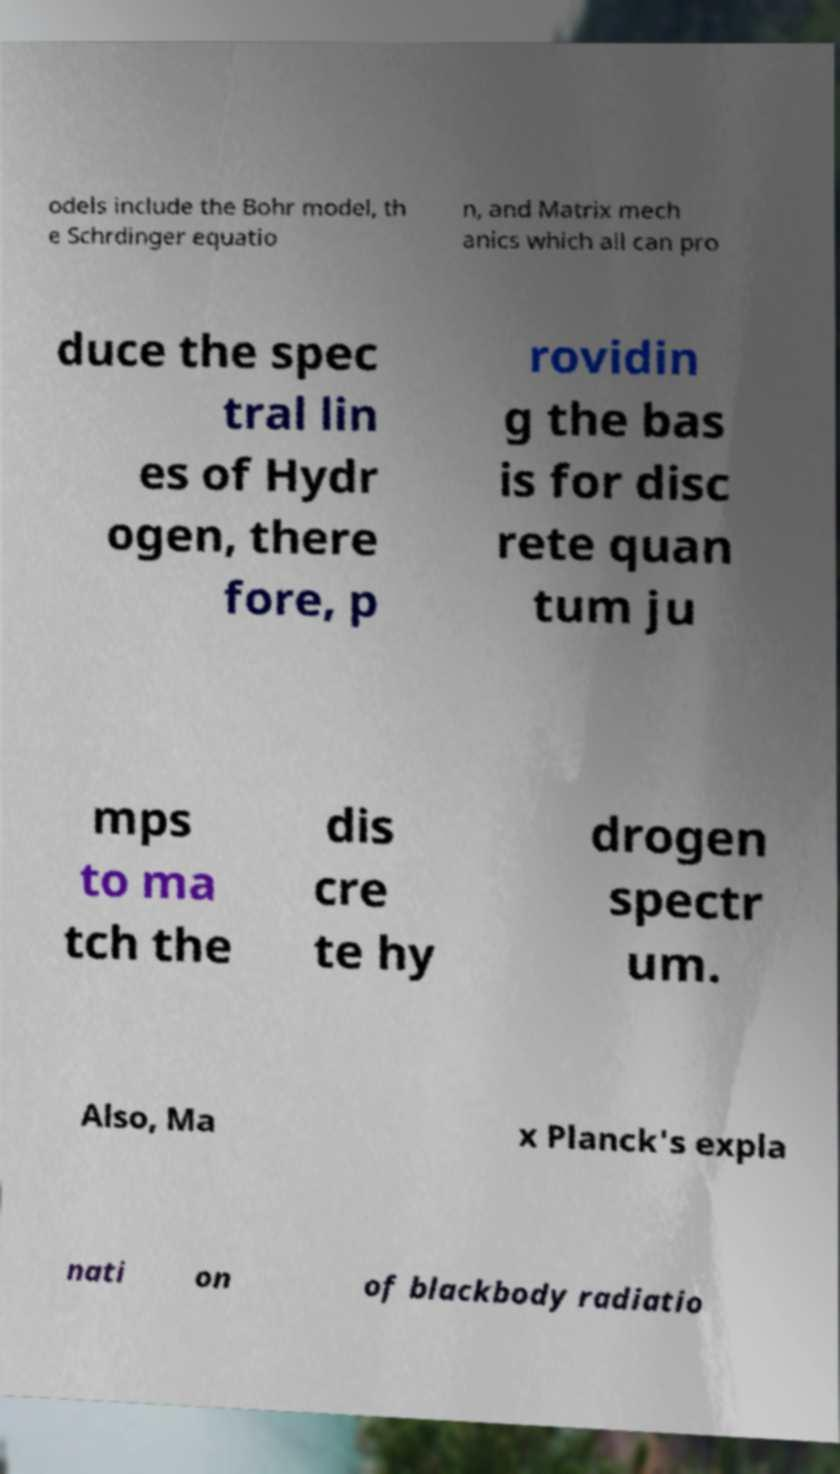Can you accurately transcribe the text from the provided image for me? odels include the Bohr model, th e Schrdinger equatio n, and Matrix mech anics which all can pro duce the spec tral lin es of Hydr ogen, there fore, p rovidin g the bas is for disc rete quan tum ju mps to ma tch the dis cre te hy drogen spectr um. Also, Ma x Planck's expla nati on of blackbody radiatio 